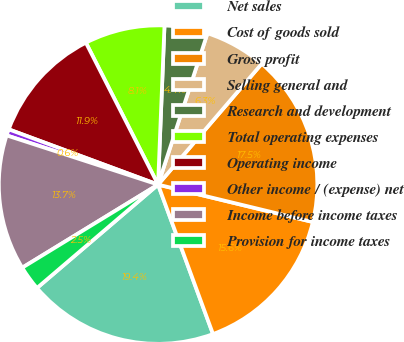<chart> <loc_0><loc_0><loc_500><loc_500><pie_chart><fcel>Net sales<fcel>Cost of goods sold<fcel>Gross profit<fcel>Selling general and<fcel>Research and development<fcel>Total operating expenses<fcel>Operating income<fcel>Other income / (expense) net<fcel>Income before income taxes<fcel>Provision for income taxes<nl><fcel>19.36%<fcel>15.62%<fcel>17.49%<fcel>6.26%<fcel>4.38%<fcel>8.13%<fcel>11.87%<fcel>0.64%<fcel>13.74%<fcel>2.51%<nl></chart> 